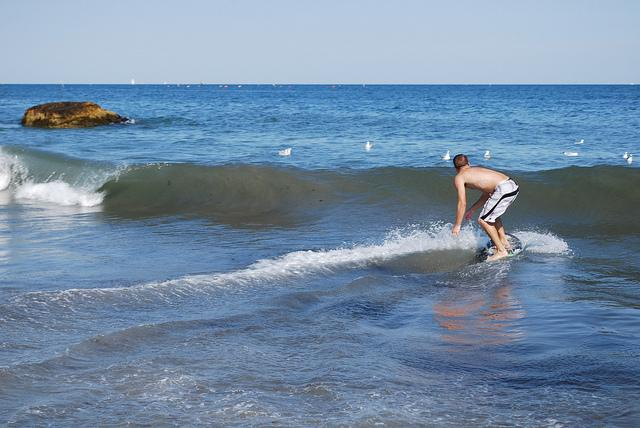Why is he crouching over? surfing 